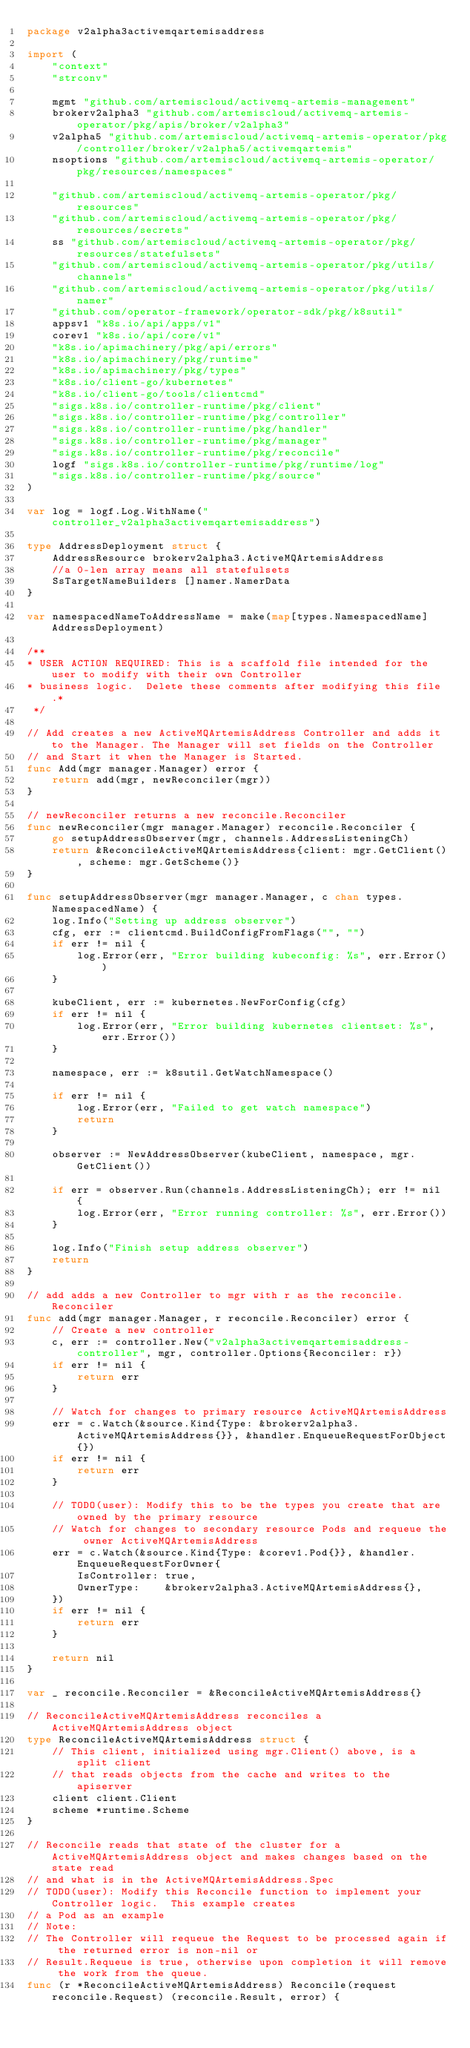<code> <loc_0><loc_0><loc_500><loc_500><_Go_>package v2alpha3activemqartemisaddress

import (
	"context"
	"strconv"

	mgmt "github.com/artemiscloud/activemq-artemis-management"
	brokerv2alpha3 "github.com/artemiscloud/activemq-artemis-operator/pkg/apis/broker/v2alpha3"
	v2alpha5 "github.com/artemiscloud/activemq-artemis-operator/pkg/controller/broker/v2alpha5/activemqartemis"
	nsoptions "github.com/artemiscloud/activemq-artemis-operator/pkg/resources/namespaces"

	"github.com/artemiscloud/activemq-artemis-operator/pkg/resources"
	"github.com/artemiscloud/activemq-artemis-operator/pkg/resources/secrets"
	ss "github.com/artemiscloud/activemq-artemis-operator/pkg/resources/statefulsets"
	"github.com/artemiscloud/activemq-artemis-operator/pkg/utils/channels"
	"github.com/artemiscloud/activemq-artemis-operator/pkg/utils/namer"
	"github.com/operator-framework/operator-sdk/pkg/k8sutil"
	appsv1 "k8s.io/api/apps/v1"
	corev1 "k8s.io/api/core/v1"
	"k8s.io/apimachinery/pkg/api/errors"
	"k8s.io/apimachinery/pkg/runtime"
	"k8s.io/apimachinery/pkg/types"
	"k8s.io/client-go/kubernetes"
	"k8s.io/client-go/tools/clientcmd"
	"sigs.k8s.io/controller-runtime/pkg/client"
	"sigs.k8s.io/controller-runtime/pkg/controller"
	"sigs.k8s.io/controller-runtime/pkg/handler"
	"sigs.k8s.io/controller-runtime/pkg/manager"
	"sigs.k8s.io/controller-runtime/pkg/reconcile"
	logf "sigs.k8s.io/controller-runtime/pkg/runtime/log"
	"sigs.k8s.io/controller-runtime/pkg/source"
)

var log = logf.Log.WithName("controller_v2alpha3activemqartemisaddress")

type AddressDeployment struct {
	AddressResource brokerv2alpha3.ActiveMQArtemisAddress
	//a 0-len array means all statefulsets
	SsTargetNameBuilders []namer.NamerData
}

var namespacedNameToAddressName = make(map[types.NamespacedName]AddressDeployment)

/**
* USER ACTION REQUIRED: This is a scaffold file intended for the user to modify with their own Controller
* business logic.  Delete these comments after modifying this file.*
 */

// Add creates a new ActiveMQArtemisAddress Controller and adds it to the Manager. The Manager will set fields on the Controller
// and Start it when the Manager is Started.
func Add(mgr manager.Manager) error {
	return add(mgr, newReconciler(mgr))
}

// newReconciler returns a new reconcile.Reconciler
func newReconciler(mgr manager.Manager) reconcile.Reconciler {
	go setupAddressObserver(mgr, channels.AddressListeningCh)
	return &ReconcileActiveMQArtemisAddress{client: mgr.GetClient(), scheme: mgr.GetScheme()}
}

func setupAddressObserver(mgr manager.Manager, c chan types.NamespacedName) {
	log.Info("Setting up address observer")
	cfg, err := clientcmd.BuildConfigFromFlags("", "")
	if err != nil {
		log.Error(err, "Error building kubeconfig: %s", err.Error())
	}

	kubeClient, err := kubernetes.NewForConfig(cfg)
	if err != nil {
		log.Error(err, "Error building kubernetes clientset: %s", err.Error())
	}

	namespace, err := k8sutil.GetWatchNamespace()

	if err != nil {
		log.Error(err, "Failed to get watch namespace")
		return
	}

	observer := NewAddressObserver(kubeClient, namespace, mgr.GetClient())

	if err = observer.Run(channels.AddressListeningCh); err != nil {
		log.Error(err, "Error running controller: %s", err.Error())
	}

	log.Info("Finish setup address observer")
	return
}

// add adds a new Controller to mgr with r as the reconcile.Reconciler
func add(mgr manager.Manager, r reconcile.Reconciler) error {
	// Create a new controller
	c, err := controller.New("v2alpha3activemqartemisaddress-controller", mgr, controller.Options{Reconciler: r})
	if err != nil {
		return err
	}

	// Watch for changes to primary resource ActiveMQArtemisAddress
	err = c.Watch(&source.Kind{Type: &brokerv2alpha3.ActiveMQArtemisAddress{}}, &handler.EnqueueRequestForObject{})
	if err != nil {
		return err
	}

	// TODO(user): Modify this to be the types you create that are owned by the primary resource
	// Watch for changes to secondary resource Pods and requeue the owner ActiveMQArtemisAddress
	err = c.Watch(&source.Kind{Type: &corev1.Pod{}}, &handler.EnqueueRequestForOwner{
		IsController: true,
		OwnerType:    &brokerv2alpha3.ActiveMQArtemisAddress{},
	})
	if err != nil {
		return err
	}

	return nil
}

var _ reconcile.Reconciler = &ReconcileActiveMQArtemisAddress{}

// ReconcileActiveMQArtemisAddress reconciles a ActiveMQArtemisAddress object
type ReconcileActiveMQArtemisAddress struct {
	// This client, initialized using mgr.Client() above, is a split client
	// that reads objects from the cache and writes to the apiserver
	client client.Client
	scheme *runtime.Scheme
}

// Reconcile reads that state of the cluster for a ActiveMQArtemisAddress object and makes changes based on the state read
// and what is in the ActiveMQArtemisAddress.Spec
// TODO(user): Modify this Reconcile function to implement your Controller logic.  This example creates
// a Pod as an example
// Note:
// The Controller will requeue the Request to be processed again if the returned error is non-nil or
// Result.Requeue is true, otherwise upon completion it will remove the work from the queue.
func (r *ReconcileActiveMQArtemisAddress) Reconcile(request reconcile.Request) (reconcile.Result, error) {
</code> 